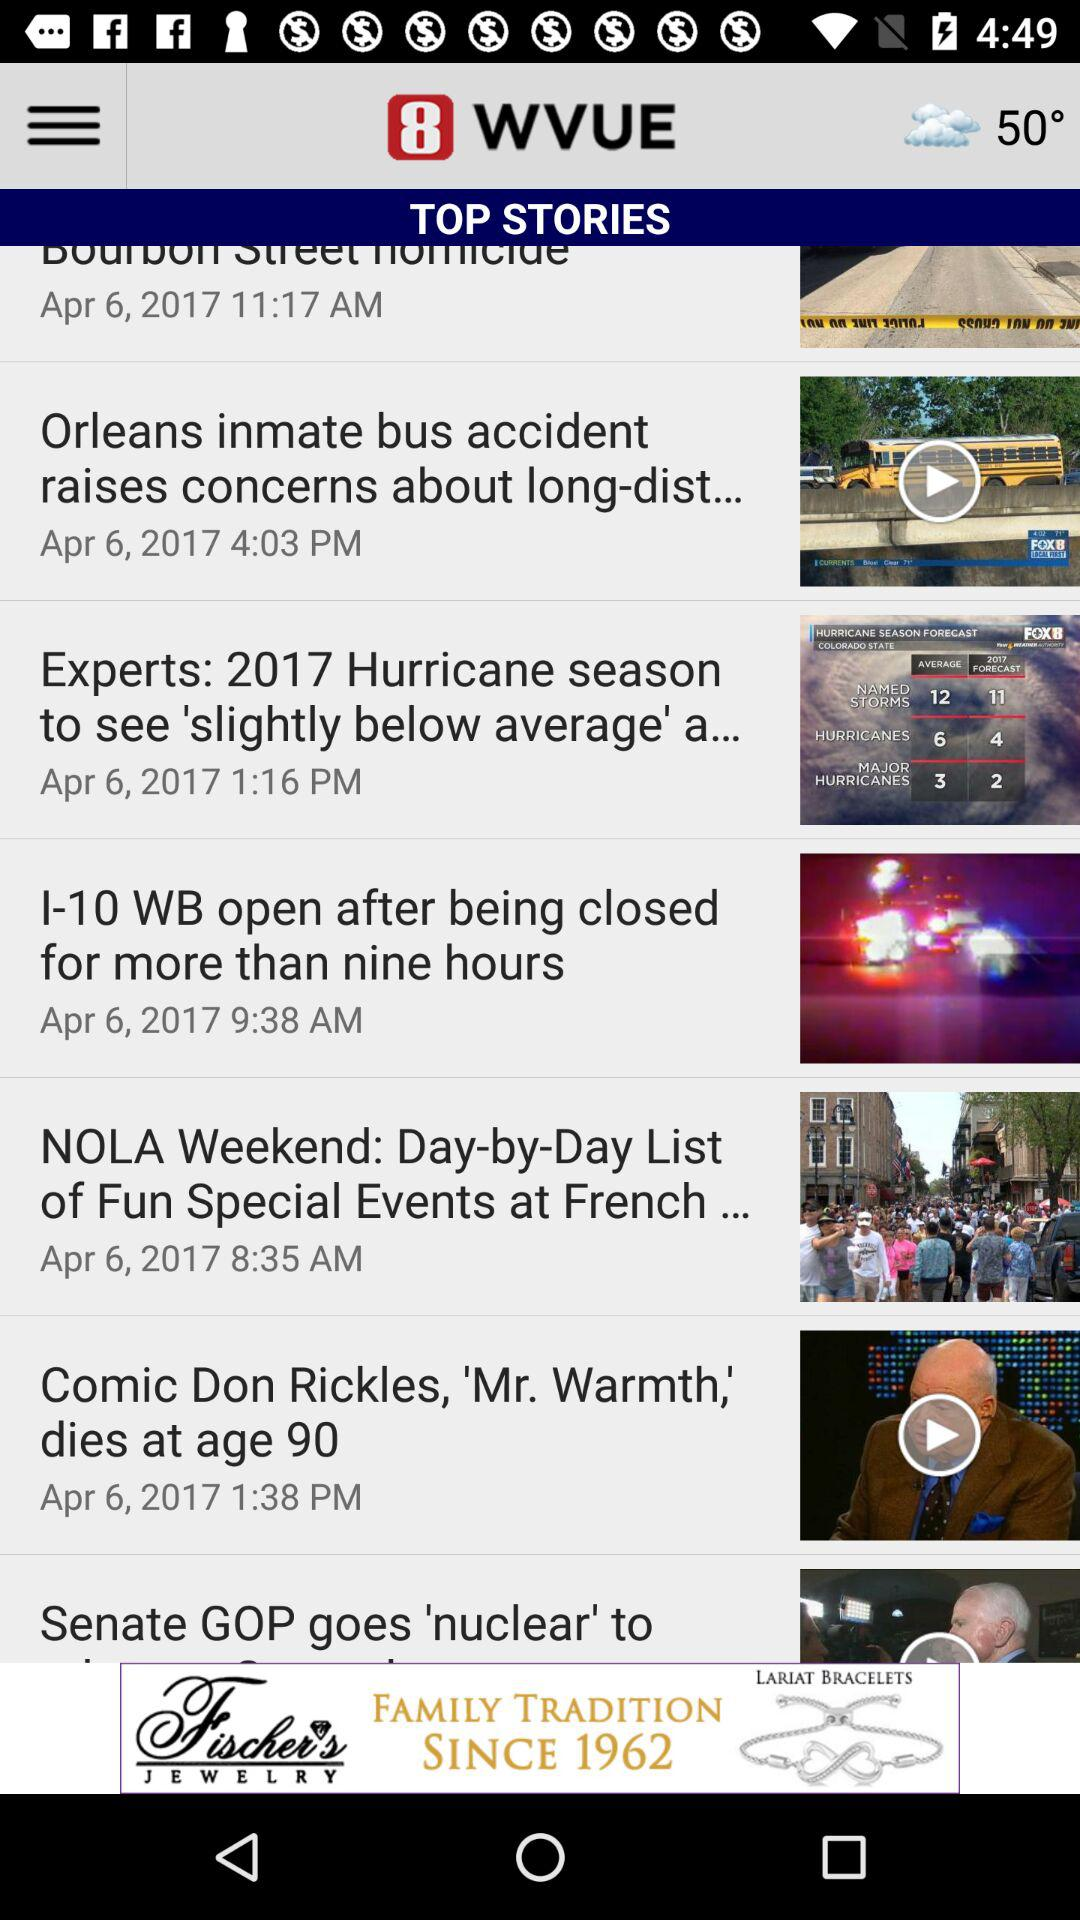What is the time of the story "I-10 WB open after being closed for more than nine hours"? The time of the story "I-10 WB open after being closed for more than nine hours" is 9:38 AM. 